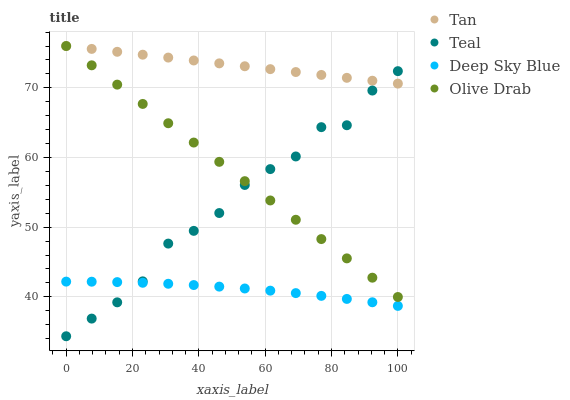Does Deep Sky Blue have the minimum area under the curve?
Answer yes or no. Yes. Does Tan have the maximum area under the curve?
Answer yes or no. Yes. Does Tan have the minimum area under the curve?
Answer yes or no. No. Does Deep Sky Blue have the maximum area under the curve?
Answer yes or no. No. Is Tan the smoothest?
Answer yes or no. Yes. Is Teal the roughest?
Answer yes or no. Yes. Is Deep Sky Blue the smoothest?
Answer yes or no. No. Is Deep Sky Blue the roughest?
Answer yes or no. No. Does Teal have the lowest value?
Answer yes or no. Yes. Does Deep Sky Blue have the lowest value?
Answer yes or no. No. Does Tan have the highest value?
Answer yes or no. Yes. Does Deep Sky Blue have the highest value?
Answer yes or no. No. Is Deep Sky Blue less than Tan?
Answer yes or no. Yes. Is Tan greater than Deep Sky Blue?
Answer yes or no. Yes. Does Olive Drab intersect Teal?
Answer yes or no. Yes. Is Olive Drab less than Teal?
Answer yes or no. No. Is Olive Drab greater than Teal?
Answer yes or no. No. Does Deep Sky Blue intersect Tan?
Answer yes or no. No. 